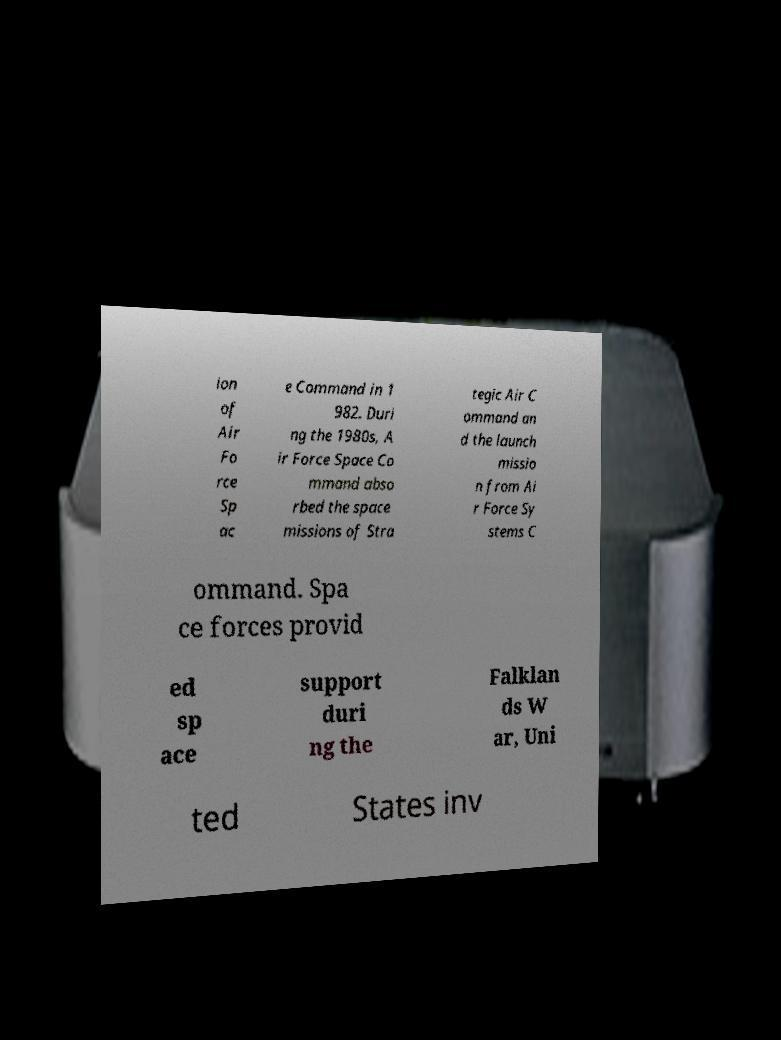Can you read and provide the text displayed in the image?This photo seems to have some interesting text. Can you extract and type it out for me? ion of Air Fo rce Sp ac e Command in 1 982. Duri ng the 1980s, A ir Force Space Co mmand abso rbed the space missions of Stra tegic Air C ommand an d the launch missio n from Ai r Force Sy stems C ommand. Spa ce forces provid ed sp ace support duri ng the Falklan ds W ar, Uni ted States inv 